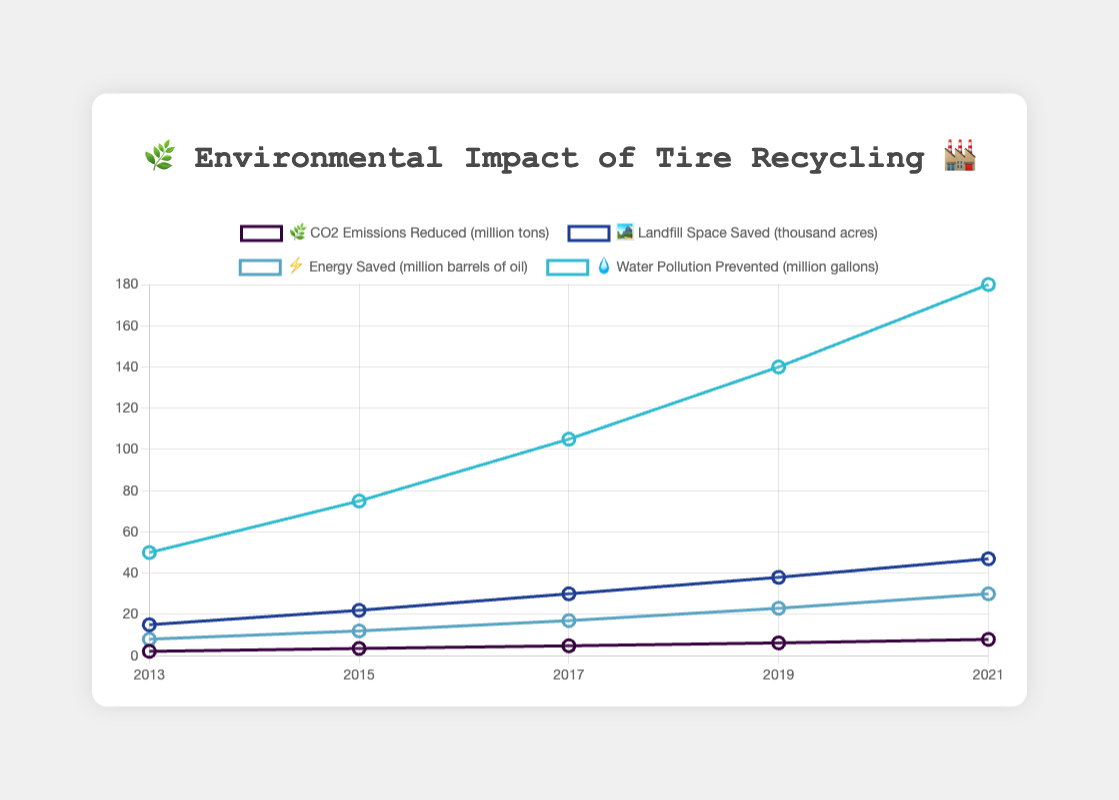What's the main title of the chart? The title is usually located at the top of the chart and gives a summary of what the chart is about. In this case, it mentions the environmental impact of tire recycling.
Answer: 🌿 Environmental Impact of Tire Recycling 🏭 How many years' worth of data are displayed? Count the distinct years on the x-axis of the chart.
Answer: 5 Which metric shows the highest values across the years? Compare the values of all metrics at each year and see which metric consistently has the highest values. The "Water Pollution Prevented" metric seems to have the highest values.
Answer: 💧 Water Pollution Prevented (million gallons) In which year did 'CO2 Emissions Reduced' see the biggest increase? Look at the values for "CO2 Emissions Reduced" in sequential years and find the pair of years with the largest difference. The largest change appears between 2013 and 2015, increasing from 2.1 to 3.5.
Answer: 2015 What was the total 'Energy Saved' from 2013 to 2021? Sum the values of "Energy Saved" from each year: 8 + 12 + 17 + 23 + 30 = 90.
Answer: 90 million barrels of oil Which metric had the smallest increase from 2013 to 2021? Calculate the difference between 2021 and 2013 values for each metric. The metric "Landfill Space Saved" increased from 15 to 47, showing the smallest increase.
Answer: 🏞️ Landfill Space Saved (thousand acres) How much 'Water Pollution Prevented' was achieved in 2021? Look at the data point for "Water Pollution Prevented" in the year 2021 on the chart.
Answer: 180 million gallons What is the average annual increase in 'CO2 Emissions Reduced' from 2013 to 2021? Find the total increase: 7.9 - 2.1 = 5.8 million tons, then divide it by the number of intervals (4). Average annual increase is 5.8/4 = 1.45.
Answer: 1.45 million tons per year Which year saw a significant rise in 'Landfill Space Saved'? Identify the year where "Landfill Space Saved" had its greatest jump between data points. The largest increase is from 2017 to 2019 (30 to 38).
Answer: 2019 Compare the 'Energy Saved' in 2015 to that in 2021. How much more energy was saved in 2021? Subtract the value of 2015 from 2021 for "Energy Saved": 30 - 12 = 18 million barrels of oil.
Answer: 18 million barrels of oil 